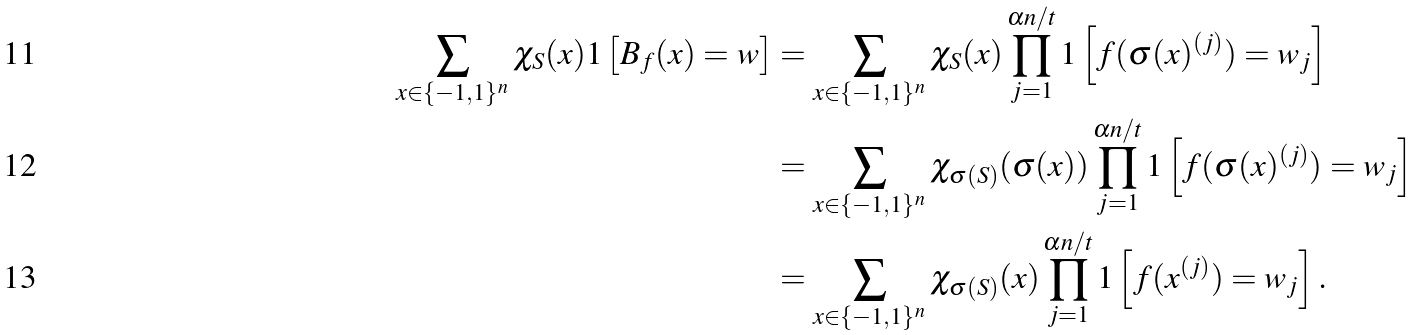<formula> <loc_0><loc_0><loc_500><loc_500>\sum _ { x \in \{ - 1 , 1 \} ^ { n } } \chi _ { S } ( x ) 1 \left [ B _ { f } ( x ) = w \right ] & = \sum _ { x \in \{ - 1 , 1 \} ^ { n } } \chi _ { S } ( x ) \prod _ { j = 1 } ^ { \alpha n / t } 1 \left [ f ( \sigma ( x ) ^ { ( j ) } ) = w _ { j } \right ] \\ & = \sum _ { x \in \{ - 1 , 1 \} ^ { n } } \chi _ { \sigma ( S ) } ( \sigma ( x ) ) \prod _ { j = 1 } ^ { \alpha n / t } 1 \left [ f ( \sigma ( x ) ^ { ( j ) } ) = w _ { j } \right ] \\ & = \sum _ { x \in \{ - 1 , 1 \} ^ { n } } \chi _ { \sigma ( S ) } ( x ) \prod _ { j = 1 } ^ { \alpha n / t } 1 \left [ f ( x ^ { ( j ) } ) = w _ { j } \right ] .</formula> 